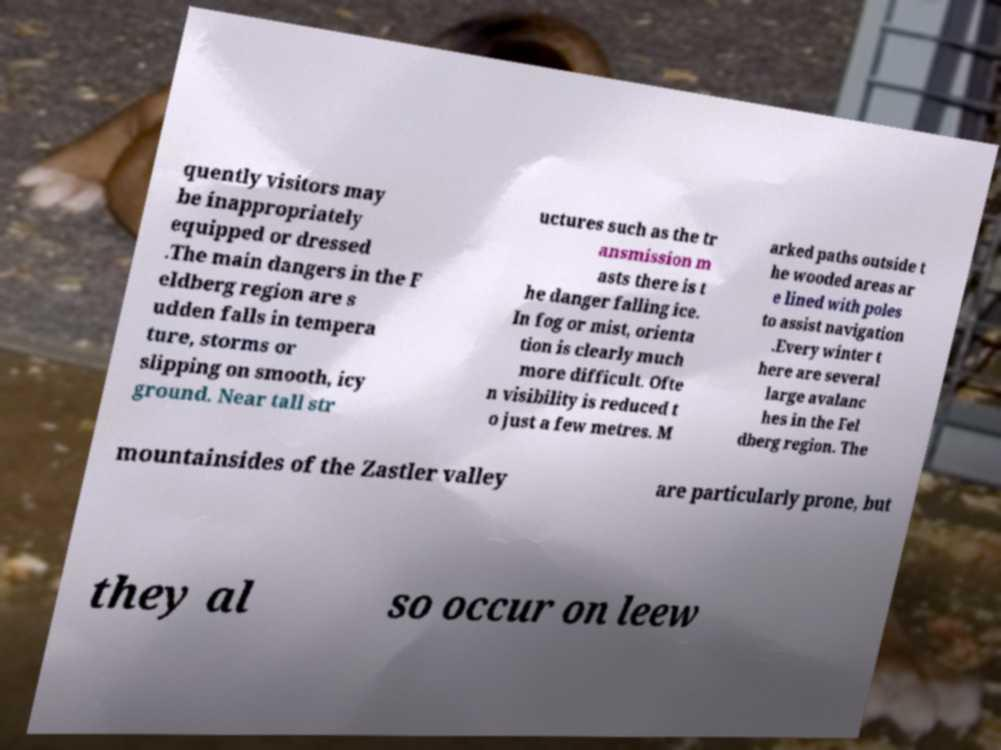Can you accurately transcribe the text from the provided image for me? quently visitors may be inappropriately equipped or dressed .The main dangers in the F eldberg region are s udden falls in tempera ture, storms or slipping on smooth, icy ground. Near tall str uctures such as the tr ansmission m asts there is t he danger falling ice. In fog or mist, orienta tion is clearly much more difficult. Ofte n visibility is reduced t o just a few metres. M arked paths outside t he wooded areas ar e lined with poles to assist navigation .Every winter t here are several large avalanc hes in the Fel dberg region. The mountainsides of the Zastler valley are particularly prone, but they al so occur on leew 